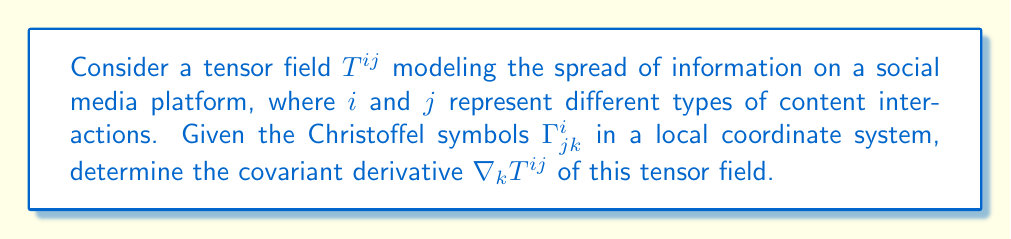Provide a solution to this math problem. To solve this problem, we'll follow these steps:

1) The covariant derivative of a contravariant tensor field $T^{ij}$ is given by:

   $$\nabla_k T^{ij} = \partial_k T^{ij} + \Gamma^i_{kl}T^{lj} + \Gamma^j_{kl}T^{il}$$

2) Here, $\partial_k T^{ij}$ represents the partial derivative of $T^{ij}$ with respect to the $k$-th coordinate.

3) The terms $\Gamma^i_{kl}T^{lj}$ and $\Gamma^j_{kl}T^{il}$ account for the curvature of the space (in this case, the complex structure of information spread on social media).

4) To calculate this:
   - First, compute $\partial_k T^{ij}$
   - Then, calculate $\Gamma^i_{kl}T^{lj}$ (sum over $l$)
   - Next, calculate $\Gamma^j_{kl}T^{il}$ (sum over $l$)
   - Finally, add all these terms together

5) The result will be a tensor of rank (2,1), representing how the information spread (modeled by $T^{ij}$) changes as we move in the $k$ direction on our social media "manifold".

This covariant derivative can help us understand how the spread of information (including misinformation) changes across different aspects of the social media platform, accounting for the platform's inherent structure and dynamics.
Answer: $$\nabla_k T^{ij} = \partial_k T^{ij} + \Gamma^i_{kl}T^{lj} + \Gamma^j_{kl}T^{il}$$ 